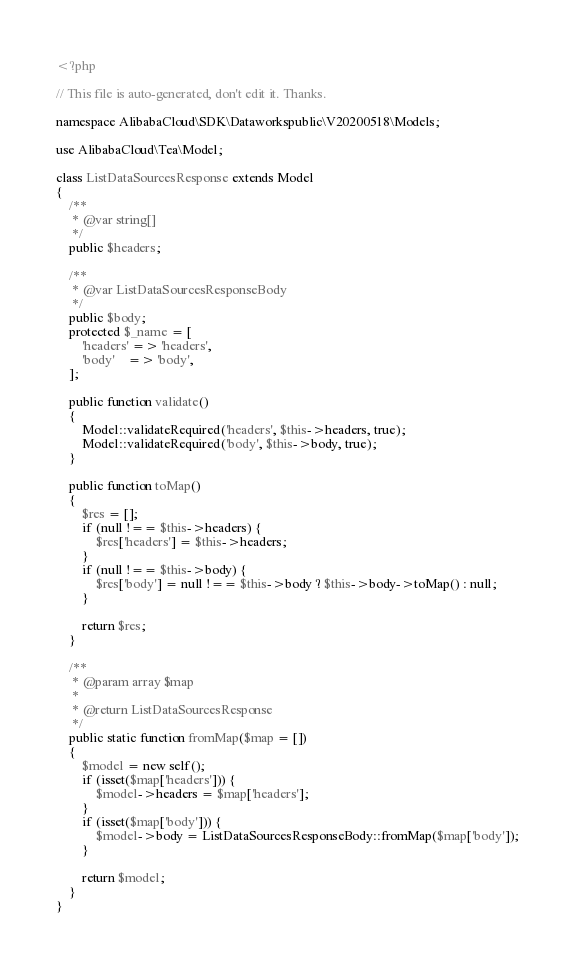Convert code to text. <code><loc_0><loc_0><loc_500><loc_500><_PHP_><?php

// This file is auto-generated, don't edit it. Thanks.

namespace AlibabaCloud\SDK\Dataworkspublic\V20200518\Models;

use AlibabaCloud\Tea\Model;

class ListDataSourcesResponse extends Model
{
    /**
     * @var string[]
     */
    public $headers;

    /**
     * @var ListDataSourcesResponseBody
     */
    public $body;
    protected $_name = [
        'headers' => 'headers',
        'body'    => 'body',
    ];

    public function validate()
    {
        Model::validateRequired('headers', $this->headers, true);
        Model::validateRequired('body', $this->body, true);
    }

    public function toMap()
    {
        $res = [];
        if (null !== $this->headers) {
            $res['headers'] = $this->headers;
        }
        if (null !== $this->body) {
            $res['body'] = null !== $this->body ? $this->body->toMap() : null;
        }

        return $res;
    }

    /**
     * @param array $map
     *
     * @return ListDataSourcesResponse
     */
    public static function fromMap($map = [])
    {
        $model = new self();
        if (isset($map['headers'])) {
            $model->headers = $map['headers'];
        }
        if (isset($map['body'])) {
            $model->body = ListDataSourcesResponseBody::fromMap($map['body']);
        }

        return $model;
    }
}
</code> 